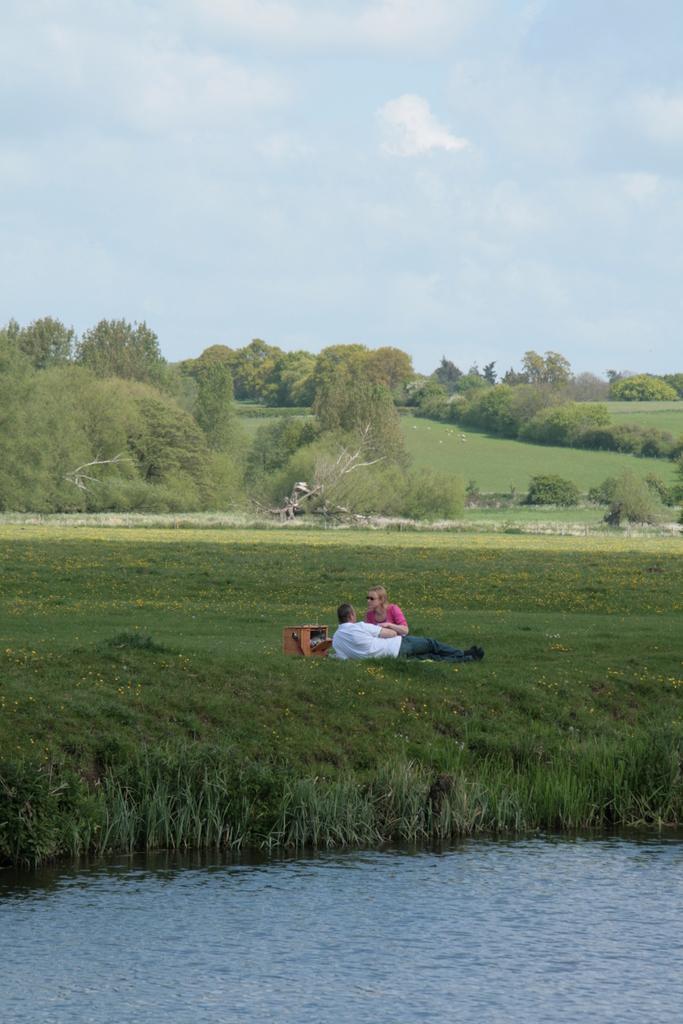How would you summarize this image in a sentence or two? At the bottom I can see water, grass and two persons. In the background I can see trees. At the top I can see the sky. This image is taken during a day may be near the lake. 